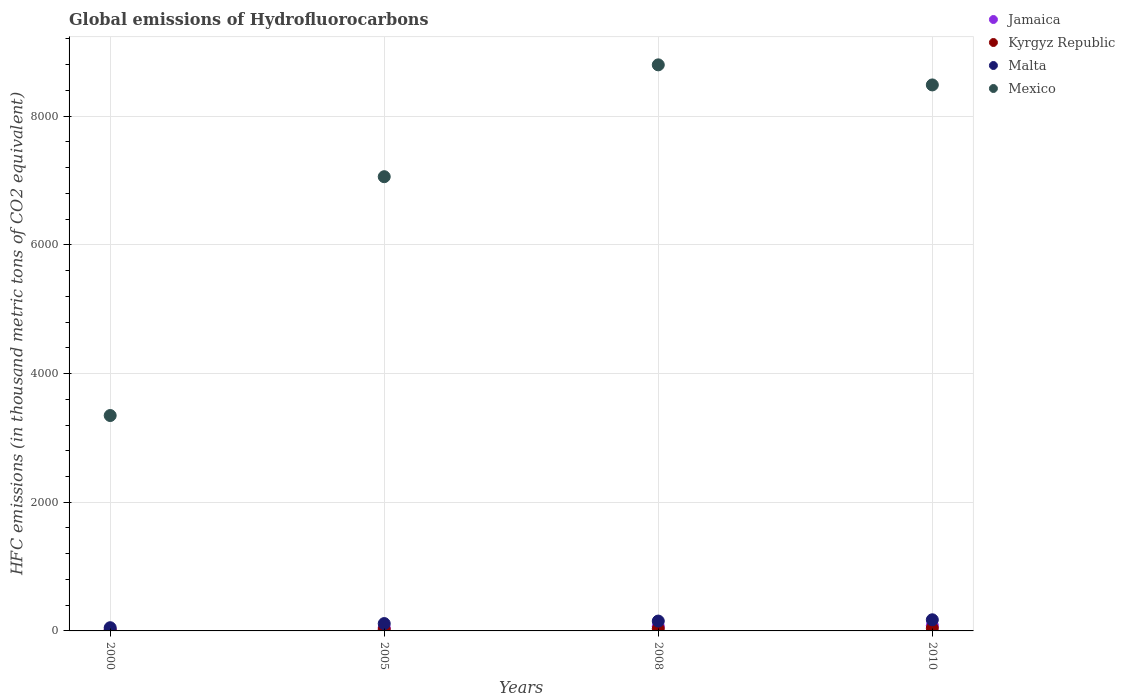How many different coloured dotlines are there?
Ensure brevity in your answer.  4. Is the number of dotlines equal to the number of legend labels?
Your answer should be very brief. Yes. What is the global emissions of Hydrofluorocarbons in Mexico in 2005?
Give a very brief answer. 7058.9. Across all years, what is the maximum global emissions of Hydrofluorocarbons in Mexico?
Offer a terse response. 8796.9. What is the total global emissions of Hydrofluorocarbons in Jamaica in the graph?
Offer a terse response. 222.4. What is the difference between the global emissions of Hydrofluorocarbons in Jamaica in 2000 and that in 2005?
Your response must be concise. -32.5. What is the average global emissions of Hydrofluorocarbons in Mexico per year?
Make the answer very short. 6922.02. In the year 2000, what is the difference between the global emissions of Hydrofluorocarbons in Malta and global emissions of Hydrofluorocarbons in Jamaica?
Make the answer very short. 32.2. In how many years, is the global emissions of Hydrofluorocarbons in Jamaica greater than 2000 thousand metric tons?
Give a very brief answer. 0. What is the ratio of the global emissions of Hydrofluorocarbons in Kyrgyz Republic in 2000 to that in 2005?
Keep it short and to the point. 0.33. Is the global emissions of Hydrofluorocarbons in Kyrgyz Republic in 2000 less than that in 2008?
Make the answer very short. Yes. Is the difference between the global emissions of Hydrofluorocarbons in Malta in 2005 and 2010 greater than the difference between the global emissions of Hydrofluorocarbons in Jamaica in 2005 and 2010?
Keep it short and to the point. No. What is the difference between the highest and the second highest global emissions of Hydrofluorocarbons in Malta?
Offer a very short reply. 19.8. What is the difference between the highest and the lowest global emissions of Hydrofluorocarbons in Malta?
Ensure brevity in your answer.  123. Is the sum of the global emissions of Hydrofluorocarbons in Mexico in 2000 and 2005 greater than the maximum global emissions of Hydrofluorocarbons in Malta across all years?
Provide a short and direct response. Yes. Is it the case that in every year, the sum of the global emissions of Hydrofluorocarbons in Malta and global emissions of Hydrofluorocarbons in Mexico  is greater than the sum of global emissions of Hydrofluorocarbons in Jamaica and global emissions of Hydrofluorocarbons in Kyrgyz Republic?
Provide a succinct answer. Yes. Is it the case that in every year, the sum of the global emissions of Hydrofluorocarbons in Mexico and global emissions of Hydrofluorocarbons in Malta  is greater than the global emissions of Hydrofluorocarbons in Kyrgyz Republic?
Provide a short and direct response. Yes. Is the global emissions of Hydrofluorocarbons in Mexico strictly greater than the global emissions of Hydrofluorocarbons in Kyrgyz Republic over the years?
Offer a terse response. Yes. Is the global emissions of Hydrofluorocarbons in Jamaica strictly less than the global emissions of Hydrofluorocarbons in Kyrgyz Republic over the years?
Keep it short and to the point. No. How many dotlines are there?
Provide a short and direct response. 4. How many years are there in the graph?
Provide a succinct answer. 4. Does the graph contain any zero values?
Make the answer very short. No. Where does the legend appear in the graph?
Make the answer very short. Top right. How many legend labels are there?
Make the answer very short. 4. What is the title of the graph?
Make the answer very short. Global emissions of Hydrofluorocarbons. What is the label or title of the Y-axis?
Keep it short and to the point. HFC emissions (in thousand metric tons of CO2 equivalent). What is the HFC emissions (in thousand metric tons of CO2 equivalent) in Jamaica in 2000?
Ensure brevity in your answer.  17.8. What is the HFC emissions (in thousand metric tons of CO2 equivalent) of Kyrgyz Republic in 2000?
Your answer should be compact. 7.9. What is the HFC emissions (in thousand metric tons of CO2 equivalent) of Malta in 2000?
Ensure brevity in your answer.  50. What is the HFC emissions (in thousand metric tons of CO2 equivalent) of Mexico in 2000?
Provide a short and direct response. 3347.3. What is the HFC emissions (in thousand metric tons of CO2 equivalent) in Jamaica in 2005?
Provide a short and direct response. 50.3. What is the HFC emissions (in thousand metric tons of CO2 equivalent) of Malta in 2005?
Your answer should be compact. 114.2. What is the HFC emissions (in thousand metric tons of CO2 equivalent) in Mexico in 2005?
Keep it short and to the point. 7058.9. What is the HFC emissions (in thousand metric tons of CO2 equivalent) in Jamaica in 2008?
Make the answer very short. 70.3. What is the HFC emissions (in thousand metric tons of CO2 equivalent) of Kyrgyz Republic in 2008?
Offer a very short reply. 34.8. What is the HFC emissions (in thousand metric tons of CO2 equivalent) in Malta in 2008?
Give a very brief answer. 153.2. What is the HFC emissions (in thousand metric tons of CO2 equivalent) in Mexico in 2008?
Your response must be concise. 8796.9. What is the HFC emissions (in thousand metric tons of CO2 equivalent) in Jamaica in 2010?
Make the answer very short. 84. What is the HFC emissions (in thousand metric tons of CO2 equivalent) in Kyrgyz Republic in 2010?
Your response must be concise. 42. What is the HFC emissions (in thousand metric tons of CO2 equivalent) in Malta in 2010?
Keep it short and to the point. 173. What is the HFC emissions (in thousand metric tons of CO2 equivalent) in Mexico in 2010?
Give a very brief answer. 8485. Across all years, what is the maximum HFC emissions (in thousand metric tons of CO2 equivalent) in Jamaica?
Offer a terse response. 84. Across all years, what is the maximum HFC emissions (in thousand metric tons of CO2 equivalent) in Malta?
Your response must be concise. 173. Across all years, what is the maximum HFC emissions (in thousand metric tons of CO2 equivalent) of Mexico?
Ensure brevity in your answer.  8796.9. Across all years, what is the minimum HFC emissions (in thousand metric tons of CO2 equivalent) in Malta?
Make the answer very short. 50. Across all years, what is the minimum HFC emissions (in thousand metric tons of CO2 equivalent) in Mexico?
Keep it short and to the point. 3347.3. What is the total HFC emissions (in thousand metric tons of CO2 equivalent) of Jamaica in the graph?
Make the answer very short. 222.4. What is the total HFC emissions (in thousand metric tons of CO2 equivalent) of Kyrgyz Republic in the graph?
Ensure brevity in your answer.  108.7. What is the total HFC emissions (in thousand metric tons of CO2 equivalent) of Malta in the graph?
Make the answer very short. 490.4. What is the total HFC emissions (in thousand metric tons of CO2 equivalent) in Mexico in the graph?
Your response must be concise. 2.77e+04. What is the difference between the HFC emissions (in thousand metric tons of CO2 equivalent) in Jamaica in 2000 and that in 2005?
Offer a terse response. -32.5. What is the difference between the HFC emissions (in thousand metric tons of CO2 equivalent) in Kyrgyz Republic in 2000 and that in 2005?
Offer a very short reply. -16.1. What is the difference between the HFC emissions (in thousand metric tons of CO2 equivalent) of Malta in 2000 and that in 2005?
Your response must be concise. -64.2. What is the difference between the HFC emissions (in thousand metric tons of CO2 equivalent) of Mexico in 2000 and that in 2005?
Ensure brevity in your answer.  -3711.6. What is the difference between the HFC emissions (in thousand metric tons of CO2 equivalent) of Jamaica in 2000 and that in 2008?
Give a very brief answer. -52.5. What is the difference between the HFC emissions (in thousand metric tons of CO2 equivalent) of Kyrgyz Republic in 2000 and that in 2008?
Keep it short and to the point. -26.9. What is the difference between the HFC emissions (in thousand metric tons of CO2 equivalent) of Malta in 2000 and that in 2008?
Your response must be concise. -103.2. What is the difference between the HFC emissions (in thousand metric tons of CO2 equivalent) in Mexico in 2000 and that in 2008?
Keep it short and to the point. -5449.6. What is the difference between the HFC emissions (in thousand metric tons of CO2 equivalent) in Jamaica in 2000 and that in 2010?
Provide a short and direct response. -66.2. What is the difference between the HFC emissions (in thousand metric tons of CO2 equivalent) in Kyrgyz Republic in 2000 and that in 2010?
Keep it short and to the point. -34.1. What is the difference between the HFC emissions (in thousand metric tons of CO2 equivalent) in Malta in 2000 and that in 2010?
Provide a short and direct response. -123. What is the difference between the HFC emissions (in thousand metric tons of CO2 equivalent) of Mexico in 2000 and that in 2010?
Make the answer very short. -5137.7. What is the difference between the HFC emissions (in thousand metric tons of CO2 equivalent) of Malta in 2005 and that in 2008?
Keep it short and to the point. -39. What is the difference between the HFC emissions (in thousand metric tons of CO2 equivalent) of Mexico in 2005 and that in 2008?
Keep it short and to the point. -1738. What is the difference between the HFC emissions (in thousand metric tons of CO2 equivalent) in Jamaica in 2005 and that in 2010?
Provide a short and direct response. -33.7. What is the difference between the HFC emissions (in thousand metric tons of CO2 equivalent) in Malta in 2005 and that in 2010?
Your answer should be compact. -58.8. What is the difference between the HFC emissions (in thousand metric tons of CO2 equivalent) in Mexico in 2005 and that in 2010?
Your answer should be compact. -1426.1. What is the difference between the HFC emissions (in thousand metric tons of CO2 equivalent) in Jamaica in 2008 and that in 2010?
Provide a short and direct response. -13.7. What is the difference between the HFC emissions (in thousand metric tons of CO2 equivalent) of Kyrgyz Republic in 2008 and that in 2010?
Provide a succinct answer. -7.2. What is the difference between the HFC emissions (in thousand metric tons of CO2 equivalent) in Malta in 2008 and that in 2010?
Ensure brevity in your answer.  -19.8. What is the difference between the HFC emissions (in thousand metric tons of CO2 equivalent) of Mexico in 2008 and that in 2010?
Give a very brief answer. 311.9. What is the difference between the HFC emissions (in thousand metric tons of CO2 equivalent) in Jamaica in 2000 and the HFC emissions (in thousand metric tons of CO2 equivalent) in Kyrgyz Republic in 2005?
Your response must be concise. -6.2. What is the difference between the HFC emissions (in thousand metric tons of CO2 equivalent) in Jamaica in 2000 and the HFC emissions (in thousand metric tons of CO2 equivalent) in Malta in 2005?
Your answer should be very brief. -96.4. What is the difference between the HFC emissions (in thousand metric tons of CO2 equivalent) in Jamaica in 2000 and the HFC emissions (in thousand metric tons of CO2 equivalent) in Mexico in 2005?
Offer a very short reply. -7041.1. What is the difference between the HFC emissions (in thousand metric tons of CO2 equivalent) of Kyrgyz Republic in 2000 and the HFC emissions (in thousand metric tons of CO2 equivalent) of Malta in 2005?
Your response must be concise. -106.3. What is the difference between the HFC emissions (in thousand metric tons of CO2 equivalent) of Kyrgyz Republic in 2000 and the HFC emissions (in thousand metric tons of CO2 equivalent) of Mexico in 2005?
Provide a short and direct response. -7051. What is the difference between the HFC emissions (in thousand metric tons of CO2 equivalent) of Malta in 2000 and the HFC emissions (in thousand metric tons of CO2 equivalent) of Mexico in 2005?
Offer a terse response. -7008.9. What is the difference between the HFC emissions (in thousand metric tons of CO2 equivalent) of Jamaica in 2000 and the HFC emissions (in thousand metric tons of CO2 equivalent) of Kyrgyz Republic in 2008?
Provide a short and direct response. -17. What is the difference between the HFC emissions (in thousand metric tons of CO2 equivalent) in Jamaica in 2000 and the HFC emissions (in thousand metric tons of CO2 equivalent) in Malta in 2008?
Ensure brevity in your answer.  -135.4. What is the difference between the HFC emissions (in thousand metric tons of CO2 equivalent) in Jamaica in 2000 and the HFC emissions (in thousand metric tons of CO2 equivalent) in Mexico in 2008?
Your response must be concise. -8779.1. What is the difference between the HFC emissions (in thousand metric tons of CO2 equivalent) in Kyrgyz Republic in 2000 and the HFC emissions (in thousand metric tons of CO2 equivalent) in Malta in 2008?
Offer a very short reply. -145.3. What is the difference between the HFC emissions (in thousand metric tons of CO2 equivalent) in Kyrgyz Republic in 2000 and the HFC emissions (in thousand metric tons of CO2 equivalent) in Mexico in 2008?
Offer a very short reply. -8789. What is the difference between the HFC emissions (in thousand metric tons of CO2 equivalent) of Malta in 2000 and the HFC emissions (in thousand metric tons of CO2 equivalent) of Mexico in 2008?
Provide a short and direct response. -8746.9. What is the difference between the HFC emissions (in thousand metric tons of CO2 equivalent) of Jamaica in 2000 and the HFC emissions (in thousand metric tons of CO2 equivalent) of Kyrgyz Republic in 2010?
Provide a succinct answer. -24.2. What is the difference between the HFC emissions (in thousand metric tons of CO2 equivalent) in Jamaica in 2000 and the HFC emissions (in thousand metric tons of CO2 equivalent) in Malta in 2010?
Your response must be concise. -155.2. What is the difference between the HFC emissions (in thousand metric tons of CO2 equivalent) of Jamaica in 2000 and the HFC emissions (in thousand metric tons of CO2 equivalent) of Mexico in 2010?
Keep it short and to the point. -8467.2. What is the difference between the HFC emissions (in thousand metric tons of CO2 equivalent) of Kyrgyz Republic in 2000 and the HFC emissions (in thousand metric tons of CO2 equivalent) of Malta in 2010?
Give a very brief answer. -165.1. What is the difference between the HFC emissions (in thousand metric tons of CO2 equivalent) in Kyrgyz Republic in 2000 and the HFC emissions (in thousand metric tons of CO2 equivalent) in Mexico in 2010?
Offer a very short reply. -8477.1. What is the difference between the HFC emissions (in thousand metric tons of CO2 equivalent) of Malta in 2000 and the HFC emissions (in thousand metric tons of CO2 equivalent) of Mexico in 2010?
Provide a short and direct response. -8435. What is the difference between the HFC emissions (in thousand metric tons of CO2 equivalent) in Jamaica in 2005 and the HFC emissions (in thousand metric tons of CO2 equivalent) in Malta in 2008?
Offer a terse response. -102.9. What is the difference between the HFC emissions (in thousand metric tons of CO2 equivalent) in Jamaica in 2005 and the HFC emissions (in thousand metric tons of CO2 equivalent) in Mexico in 2008?
Make the answer very short. -8746.6. What is the difference between the HFC emissions (in thousand metric tons of CO2 equivalent) of Kyrgyz Republic in 2005 and the HFC emissions (in thousand metric tons of CO2 equivalent) of Malta in 2008?
Offer a very short reply. -129.2. What is the difference between the HFC emissions (in thousand metric tons of CO2 equivalent) of Kyrgyz Republic in 2005 and the HFC emissions (in thousand metric tons of CO2 equivalent) of Mexico in 2008?
Keep it short and to the point. -8772.9. What is the difference between the HFC emissions (in thousand metric tons of CO2 equivalent) in Malta in 2005 and the HFC emissions (in thousand metric tons of CO2 equivalent) in Mexico in 2008?
Make the answer very short. -8682.7. What is the difference between the HFC emissions (in thousand metric tons of CO2 equivalent) of Jamaica in 2005 and the HFC emissions (in thousand metric tons of CO2 equivalent) of Kyrgyz Republic in 2010?
Give a very brief answer. 8.3. What is the difference between the HFC emissions (in thousand metric tons of CO2 equivalent) of Jamaica in 2005 and the HFC emissions (in thousand metric tons of CO2 equivalent) of Malta in 2010?
Ensure brevity in your answer.  -122.7. What is the difference between the HFC emissions (in thousand metric tons of CO2 equivalent) in Jamaica in 2005 and the HFC emissions (in thousand metric tons of CO2 equivalent) in Mexico in 2010?
Your response must be concise. -8434.7. What is the difference between the HFC emissions (in thousand metric tons of CO2 equivalent) of Kyrgyz Republic in 2005 and the HFC emissions (in thousand metric tons of CO2 equivalent) of Malta in 2010?
Your answer should be compact. -149. What is the difference between the HFC emissions (in thousand metric tons of CO2 equivalent) in Kyrgyz Republic in 2005 and the HFC emissions (in thousand metric tons of CO2 equivalent) in Mexico in 2010?
Offer a very short reply. -8461. What is the difference between the HFC emissions (in thousand metric tons of CO2 equivalent) in Malta in 2005 and the HFC emissions (in thousand metric tons of CO2 equivalent) in Mexico in 2010?
Ensure brevity in your answer.  -8370.8. What is the difference between the HFC emissions (in thousand metric tons of CO2 equivalent) of Jamaica in 2008 and the HFC emissions (in thousand metric tons of CO2 equivalent) of Kyrgyz Republic in 2010?
Provide a succinct answer. 28.3. What is the difference between the HFC emissions (in thousand metric tons of CO2 equivalent) of Jamaica in 2008 and the HFC emissions (in thousand metric tons of CO2 equivalent) of Malta in 2010?
Offer a very short reply. -102.7. What is the difference between the HFC emissions (in thousand metric tons of CO2 equivalent) in Jamaica in 2008 and the HFC emissions (in thousand metric tons of CO2 equivalent) in Mexico in 2010?
Keep it short and to the point. -8414.7. What is the difference between the HFC emissions (in thousand metric tons of CO2 equivalent) in Kyrgyz Republic in 2008 and the HFC emissions (in thousand metric tons of CO2 equivalent) in Malta in 2010?
Offer a terse response. -138.2. What is the difference between the HFC emissions (in thousand metric tons of CO2 equivalent) in Kyrgyz Republic in 2008 and the HFC emissions (in thousand metric tons of CO2 equivalent) in Mexico in 2010?
Provide a short and direct response. -8450.2. What is the difference between the HFC emissions (in thousand metric tons of CO2 equivalent) in Malta in 2008 and the HFC emissions (in thousand metric tons of CO2 equivalent) in Mexico in 2010?
Provide a succinct answer. -8331.8. What is the average HFC emissions (in thousand metric tons of CO2 equivalent) in Jamaica per year?
Offer a terse response. 55.6. What is the average HFC emissions (in thousand metric tons of CO2 equivalent) of Kyrgyz Republic per year?
Your response must be concise. 27.18. What is the average HFC emissions (in thousand metric tons of CO2 equivalent) of Malta per year?
Keep it short and to the point. 122.6. What is the average HFC emissions (in thousand metric tons of CO2 equivalent) of Mexico per year?
Provide a succinct answer. 6922.02. In the year 2000, what is the difference between the HFC emissions (in thousand metric tons of CO2 equivalent) of Jamaica and HFC emissions (in thousand metric tons of CO2 equivalent) of Kyrgyz Republic?
Your answer should be very brief. 9.9. In the year 2000, what is the difference between the HFC emissions (in thousand metric tons of CO2 equivalent) in Jamaica and HFC emissions (in thousand metric tons of CO2 equivalent) in Malta?
Keep it short and to the point. -32.2. In the year 2000, what is the difference between the HFC emissions (in thousand metric tons of CO2 equivalent) of Jamaica and HFC emissions (in thousand metric tons of CO2 equivalent) of Mexico?
Provide a succinct answer. -3329.5. In the year 2000, what is the difference between the HFC emissions (in thousand metric tons of CO2 equivalent) of Kyrgyz Republic and HFC emissions (in thousand metric tons of CO2 equivalent) of Malta?
Your response must be concise. -42.1. In the year 2000, what is the difference between the HFC emissions (in thousand metric tons of CO2 equivalent) of Kyrgyz Republic and HFC emissions (in thousand metric tons of CO2 equivalent) of Mexico?
Provide a succinct answer. -3339.4. In the year 2000, what is the difference between the HFC emissions (in thousand metric tons of CO2 equivalent) in Malta and HFC emissions (in thousand metric tons of CO2 equivalent) in Mexico?
Provide a succinct answer. -3297.3. In the year 2005, what is the difference between the HFC emissions (in thousand metric tons of CO2 equivalent) of Jamaica and HFC emissions (in thousand metric tons of CO2 equivalent) of Kyrgyz Republic?
Provide a succinct answer. 26.3. In the year 2005, what is the difference between the HFC emissions (in thousand metric tons of CO2 equivalent) in Jamaica and HFC emissions (in thousand metric tons of CO2 equivalent) in Malta?
Ensure brevity in your answer.  -63.9. In the year 2005, what is the difference between the HFC emissions (in thousand metric tons of CO2 equivalent) of Jamaica and HFC emissions (in thousand metric tons of CO2 equivalent) of Mexico?
Your answer should be compact. -7008.6. In the year 2005, what is the difference between the HFC emissions (in thousand metric tons of CO2 equivalent) of Kyrgyz Republic and HFC emissions (in thousand metric tons of CO2 equivalent) of Malta?
Your response must be concise. -90.2. In the year 2005, what is the difference between the HFC emissions (in thousand metric tons of CO2 equivalent) of Kyrgyz Republic and HFC emissions (in thousand metric tons of CO2 equivalent) of Mexico?
Make the answer very short. -7034.9. In the year 2005, what is the difference between the HFC emissions (in thousand metric tons of CO2 equivalent) in Malta and HFC emissions (in thousand metric tons of CO2 equivalent) in Mexico?
Offer a terse response. -6944.7. In the year 2008, what is the difference between the HFC emissions (in thousand metric tons of CO2 equivalent) in Jamaica and HFC emissions (in thousand metric tons of CO2 equivalent) in Kyrgyz Republic?
Keep it short and to the point. 35.5. In the year 2008, what is the difference between the HFC emissions (in thousand metric tons of CO2 equivalent) in Jamaica and HFC emissions (in thousand metric tons of CO2 equivalent) in Malta?
Offer a terse response. -82.9. In the year 2008, what is the difference between the HFC emissions (in thousand metric tons of CO2 equivalent) of Jamaica and HFC emissions (in thousand metric tons of CO2 equivalent) of Mexico?
Provide a succinct answer. -8726.6. In the year 2008, what is the difference between the HFC emissions (in thousand metric tons of CO2 equivalent) in Kyrgyz Republic and HFC emissions (in thousand metric tons of CO2 equivalent) in Malta?
Make the answer very short. -118.4. In the year 2008, what is the difference between the HFC emissions (in thousand metric tons of CO2 equivalent) in Kyrgyz Republic and HFC emissions (in thousand metric tons of CO2 equivalent) in Mexico?
Your response must be concise. -8762.1. In the year 2008, what is the difference between the HFC emissions (in thousand metric tons of CO2 equivalent) in Malta and HFC emissions (in thousand metric tons of CO2 equivalent) in Mexico?
Give a very brief answer. -8643.7. In the year 2010, what is the difference between the HFC emissions (in thousand metric tons of CO2 equivalent) in Jamaica and HFC emissions (in thousand metric tons of CO2 equivalent) in Malta?
Ensure brevity in your answer.  -89. In the year 2010, what is the difference between the HFC emissions (in thousand metric tons of CO2 equivalent) in Jamaica and HFC emissions (in thousand metric tons of CO2 equivalent) in Mexico?
Ensure brevity in your answer.  -8401. In the year 2010, what is the difference between the HFC emissions (in thousand metric tons of CO2 equivalent) in Kyrgyz Republic and HFC emissions (in thousand metric tons of CO2 equivalent) in Malta?
Give a very brief answer. -131. In the year 2010, what is the difference between the HFC emissions (in thousand metric tons of CO2 equivalent) in Kyrgyz Republic and HFC emissions (in thousand metric tons of CO2 equivalent) in Mexico?
Make the answer very short. -8443. In the year 2010, what is the difference between the HFC emissions (in thousand metric tons of CO2 equivalent) of Malta and HFC emissions (in thousand metric tons of CO2 equivalent) of Mexico?
Provide a succinct answer. -8312. What is the ratio of the HFC emissions (in thousand metric tons of CO2 equivalent) of Jamaica in 2000 to that in 2005?
Your response must be concise. 0.35. What is the ratio of the HFC emissions (in thousand metric tons of CO2 equivalent) in Kyrgyz Republic in 2000 to that in 2005?
Your answer should be compact. 0.33. What is the ratio of the HFC emissions (in thousand metric tons of CO2 equivalent) in Malta in 2000 to that in 2005?
Provide a short and direct response. 0.44. What is the ratio of the HFC emissions (in thousand metric tons of CO2 equivalent) in Mexico in 2000 to that in 2005?
Ensure brevity in your answer.  0.47. What is the ratio of the HFC emissions (in thousand metric tons of CO2 equivalent) in Jamaica in 2000 to that in 2008?
Offer a very short reply. 0.25. What is the ratio of the HFC emissions (in thousand metric tons of CO2 equivalent) in Kyrgyz Republic in 2000 to that in 2008?
Offer a very short reply. 0.23. What is the ratio of the HFC emissions (in thousand metric tons of CO2 equivalent) of Malta in 2000 to that in 2008?
Your response must be concise. 0.33. What is the ratio of the HFC emissions (in thousand metric tons of CO2 equivalent) in Mexico in 2000 to that in 2008?
Ensure brevity in your answer.  0.38. What is the ratio of the HFC emissions (in thousand metric tons of CO2 equivalent) in Jamaica in 2000 to that in 2010?
Ensure brevity in your answer.  0.21. What is the ratio of the HFC emissions (in thousand metric tons of CO2 equivalent) of Kyrgyz Republic in 2000 to that in 2010?
Make the answer very short. 0.19. What is the ratio of the HFC emissions (in thousand metric tons of CO2 equivalent) of Malta in 2000 to that in 2010?
Give a very brief answer. 0.29. What is the ratio of the HFC emissions (in thousand metric tons of CO2 equivalent) of Mexico in 2000 to that in 2010?
Offer a very short reply. 0.39. What is the ratio of the HFC emissions (in thousand metric tons of CO2 equivalent) of Jamaica in 2005 to that in 2008?
Your response must be concise. 0.72. What is the ratio of the HFC emissions (in thousand metric tons of CO2 equivalent) of Kyrgyz Republic in 2005 to that in 2008?
Offer a very short reply. 0.69. What is the ratio of the HFC emissions (in thousand metric tons of CO2 equivalent) in Malta in 2005 to that in 2008?
Ensure brevity in your answer.  0.75. What is the ratio of the HFC emissions (in thousand metric tons of CO2 equivalent) of Mexico in 2005 to that in 2008?
Your answer should be compact. 0.8. What is the ratio of the HFC emissions (in thousand metric tons of CO2 equivalent) of Jamaica in 2005 to that in 2010?
Your answer should be very brief. 0.6. What is the ratio of the HFC emissions (in thousand metric tons of CO2 equivalent) in Kyrgyz Republic in 2005 to that in 2010?
Make the answer very short. 0.57. What is the ratio of the HFC emissions (in thousand metric tons of CO2 equivalent) of Malta in 2005 to that in 2010?
Offer a terse response. 0.66. What is the ratio of the HFC emissions (in thousand metric tons of CO2 equivalent) in Mexico in 2005 to that in 2010?
Your answer should be compact. 0.83. What is the ratio of the HFC emissions (in thousand metric tons of CO2 equivalent) in Jamaica in 2008 to that in 2010?
Your answer should be compact. 0.84. What is the ratio of the HFC emissions (in thousand metric tons of CO2 equivalent) in Kyrgyz Republic in 2008 to that in 2010?
Provide a succinct answer. 0.83. What is the ratio of the HFC emissions (in thousand metric tons of CO2 equivalent) of Malta in 2008 to that in 2010?
Your answer should be very brief. 0.89. What is the ratio of the HFC emissions (in thousand metric tons of CO2 equivalent) of Mexico in 2008 to that in 2010?
Provide a short and direct response. 1.04. What is the difference between the highest and the second highest HFC emissions (in thousand metric tons of CO2 equivalent) of Malta?
Give a very brief answer. 19.8. What is the difference between the highest and the second highest HFC emissions (in thousand metric tons of CO2 equivalent) of Mexico?
Keep it short and to the point. 311.9. What is the difference between the highest and the lowest HFC emissions (in thousand metric tons of CO2 equivalent) in Jamaica?
Provide a succinct answer. 66.2. What is the difference between the highest and the lowest HFC emissions (in thousand metric tons of CO2 equivalent) in Kyrgyz Republic?
Provide a short and direct response. 34.1. What is the difference between the highest and the lowest HFC emissions (in thousand metric tons of CO2 equivalent) in Malta?
Offer a terse response. 123. What is the difference between the highest and the lowest HFC emissions (in thousand metric tons of CO2 equivalent) of Mexico?
Offer a terse response. 5449.6. 